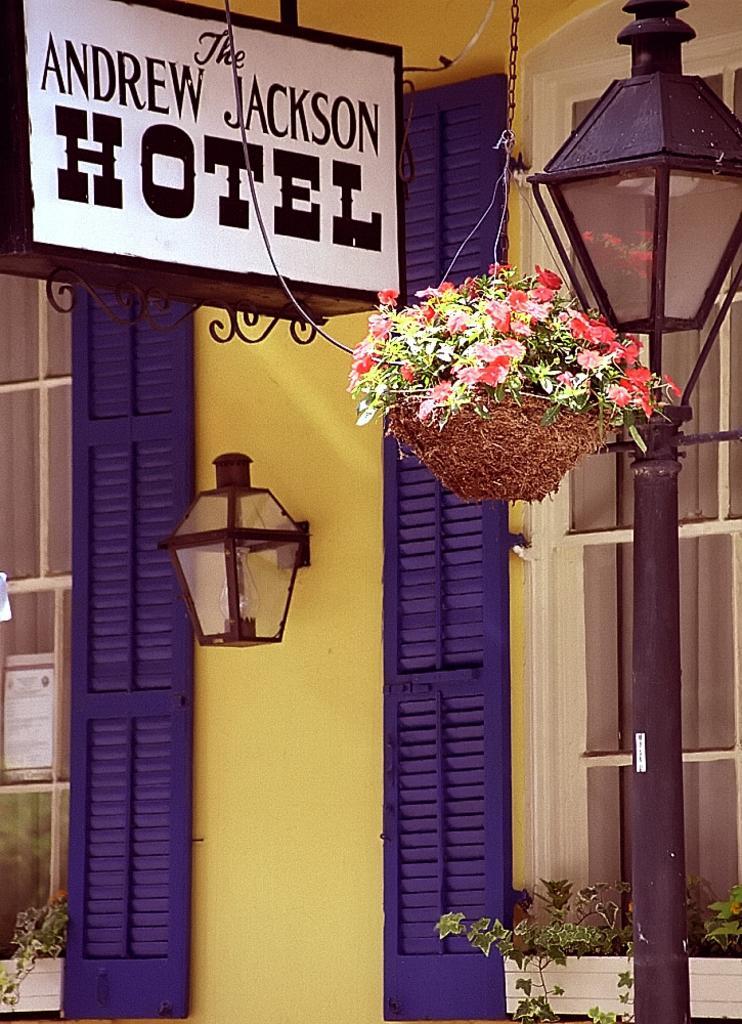In one or two sentences, can you explain what this image depicts? In the image there is a street light. A pot is hanging. The pot is having plants with flowers. In the pot there are plants having some flowers. Background there is a wall having windows. A lamp is attached to the wall having creeper plants. 